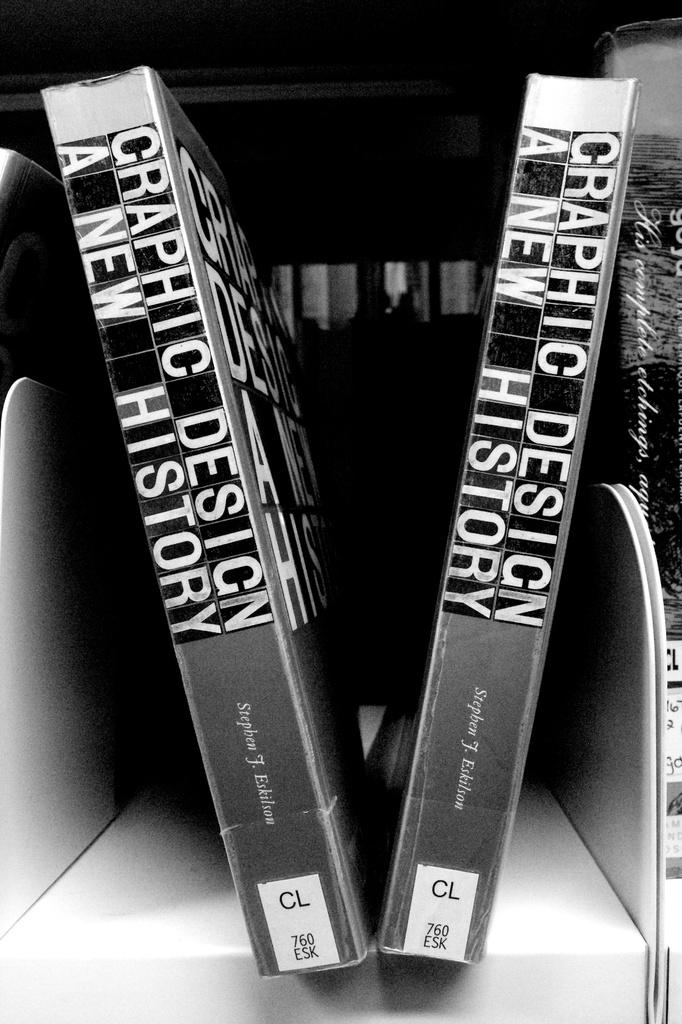What letters on the spine of book at bottom?
Your answer should be very brief. Cl. 